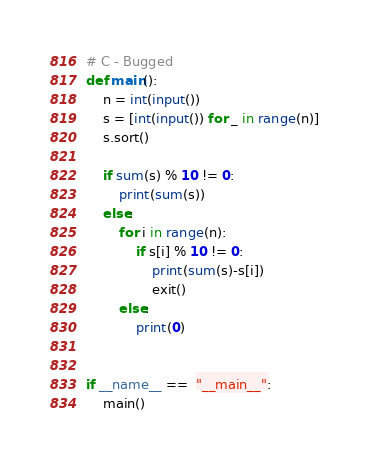Convert code to text. <code><loc_0><loc_0><loc_500><loc_500><_Python_># C - Bugged
def main():
    n = int(input())
    s = [int(input()) for _ in range(n)]
    s.sort()
  
    if sum(s) % 10 != 0:
        print(sum(s))
    else:
        for i in range(n):
            if s[i] % 10 != 0:
                print(sum(s)-s[i])
                exit()
        else:
            print(0)


if __name__ ==  "__main__":
    main()</code> 